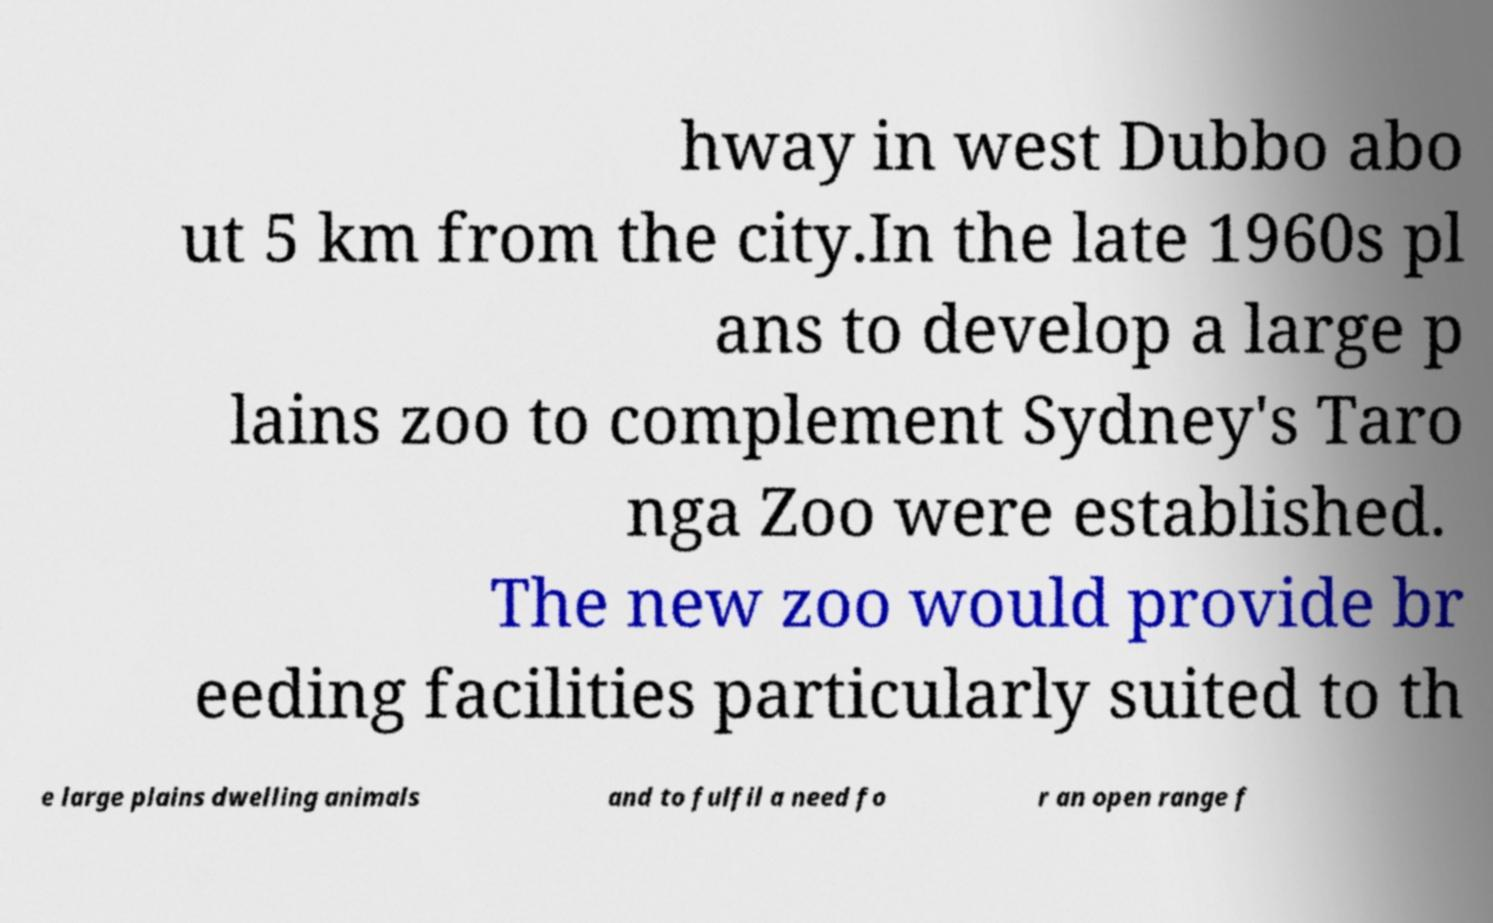Please read and relay the text visible in this image. What does it say? hway in west Dubbo abo ut 5 km from the city.In the late 1960s pl ans to develop a large p lains zoo to complement Sydney's Taro nga Zoo were established. The new zoo would provide br eeding facilities particularly suited to th e large plains dwelling animals and to fulfil a need fo r an open range f 